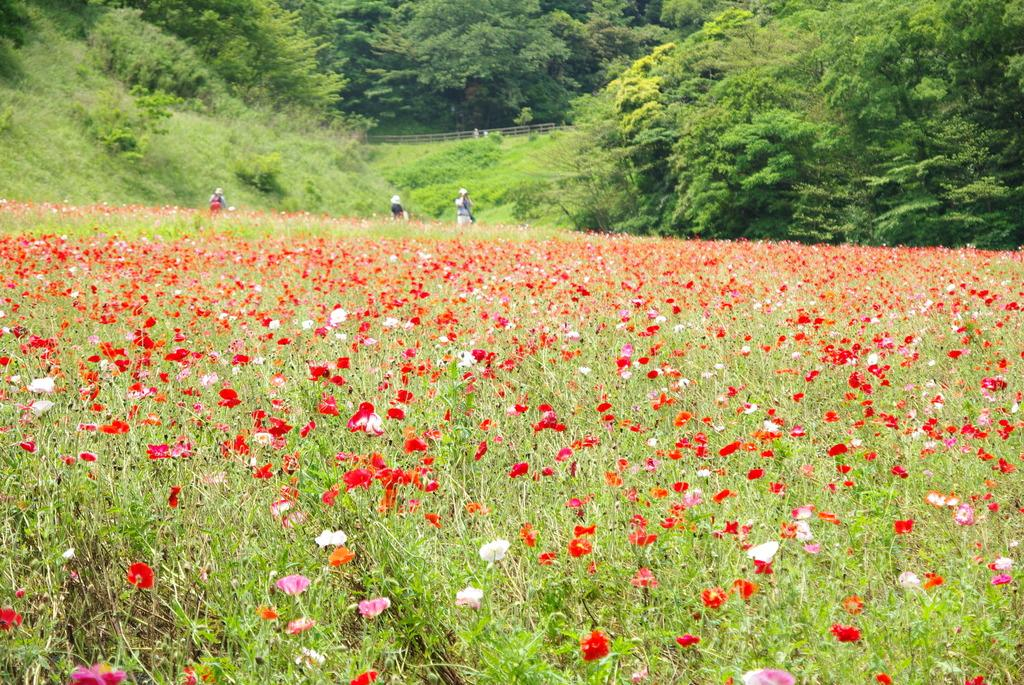What is the setting of the image? The image has an outside view. What can be seen in the foreground of the image? There are plants with flowers in the foreground. What is visible in the background of the image? There are trees in the background. What type of linen is draped over the plants in the image? There is no linen present in the image; it features plants with flowers in the foreground and trees in the background. 